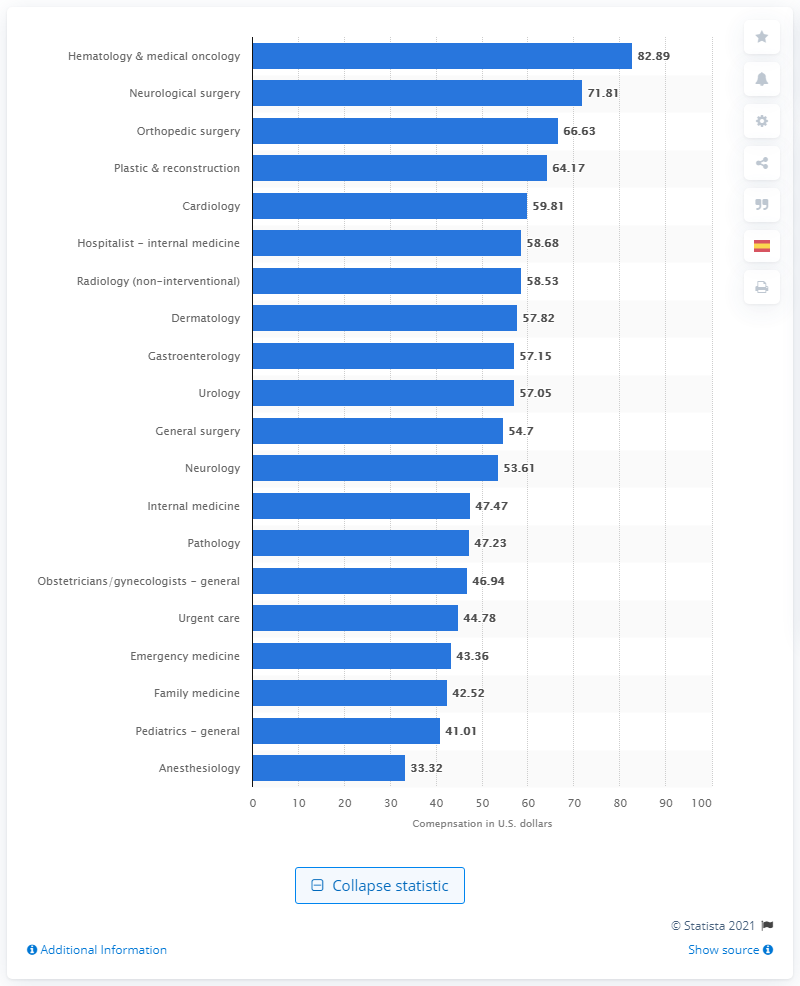Identify some key points in this picture. The median compensation per work RVU of family medicine physicians in the United States in 2013 was $42.52. 